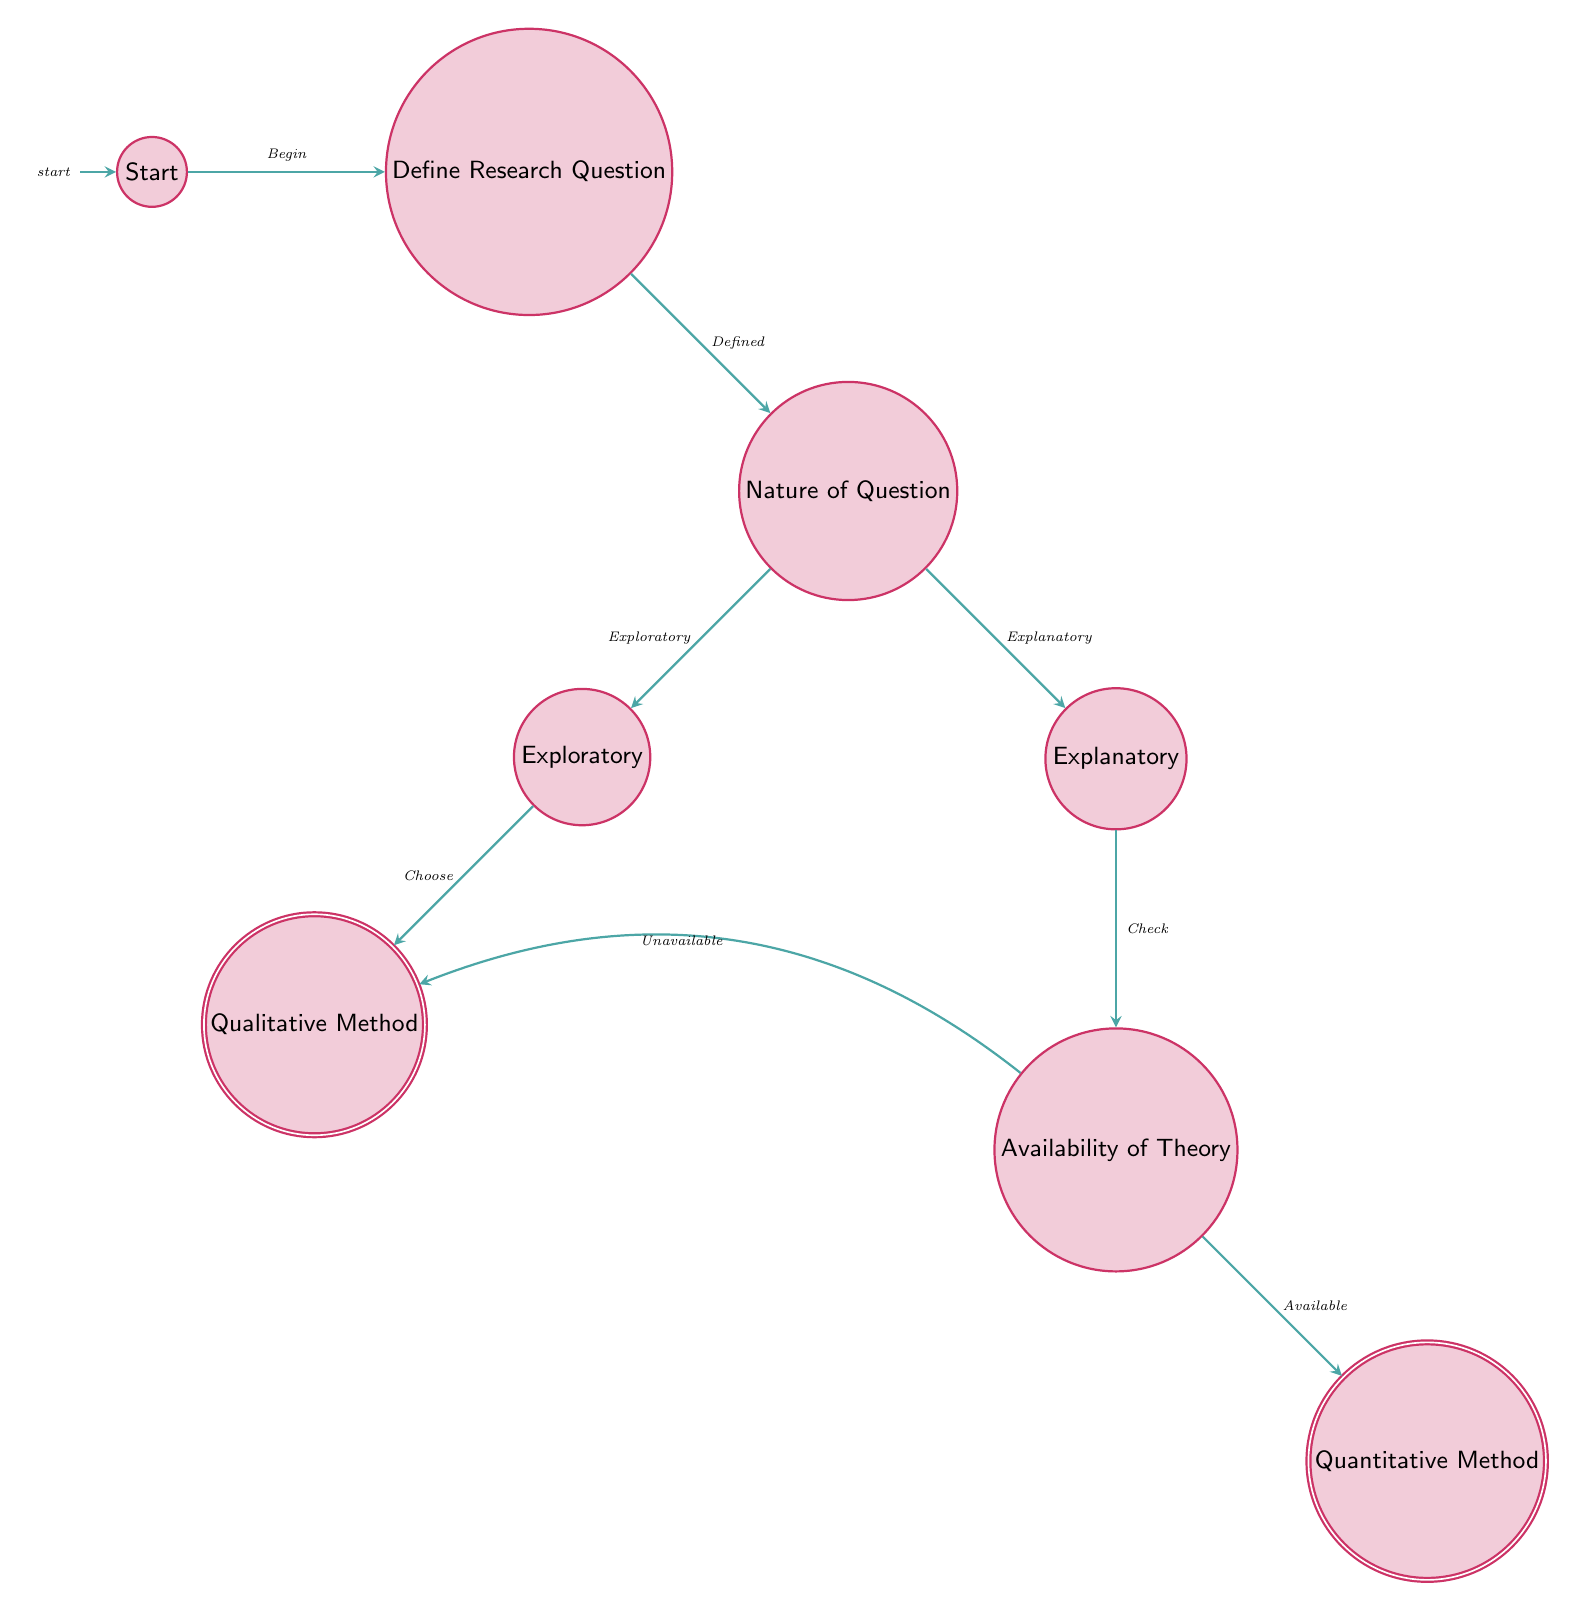What is the starting state of the decision process? The diagram begins with the "Start" state, indicating the initial point of the decision-making flow.
Answer: Start How many states are represented in the diagram? Counting all the nodes, there are a total of seven states in the diagram including the start and accepting states.
Answer: Seven What is the next state after defining the research question? The transition from "Define Research Question" leads directly to the state "Nature of Question," which is the following step in the process.
Answer: Nature of Question If the research question is exploratory, what methodology will be selected? The flow indicates that if the question is identified as exploratory, the next step is to choose "Qualitative Method."
Answer: Qualitative Method What does the decision process check for after classifying the research question as explanatory? After recognizing the question as explanatory, the process checks for the "Availability of Theory" to guide the next choice of methodology.
Answer: Availability of Theory What happens if theory is available after an explanatory question? If there is a theory available, the decision leads to selecting the "Quantitative Method" for research methodology.
Answer: Quantitative Method What is the transition condition from "Nature of Question" to "Exploratory Question"? The transition condition is stated as "Question is exploratory," guiding the decision-making from one state to another based on the nature of the research question.
Answer: Question is exploratory How many accepting states are in the diagram? The diagram displays two accepting states, which are "Qualitative Method" and "Quantitative Method," representing the outcomes of the decision process.
Answer: Two What is the condition to transition from "Availability of Theory" to "Qualitative Method"? The transition condition is "Theory unavailable," meaning if there is no theoretical framework, the decision will result in selecting a qualitative method.
Answer: Theory unavailable 